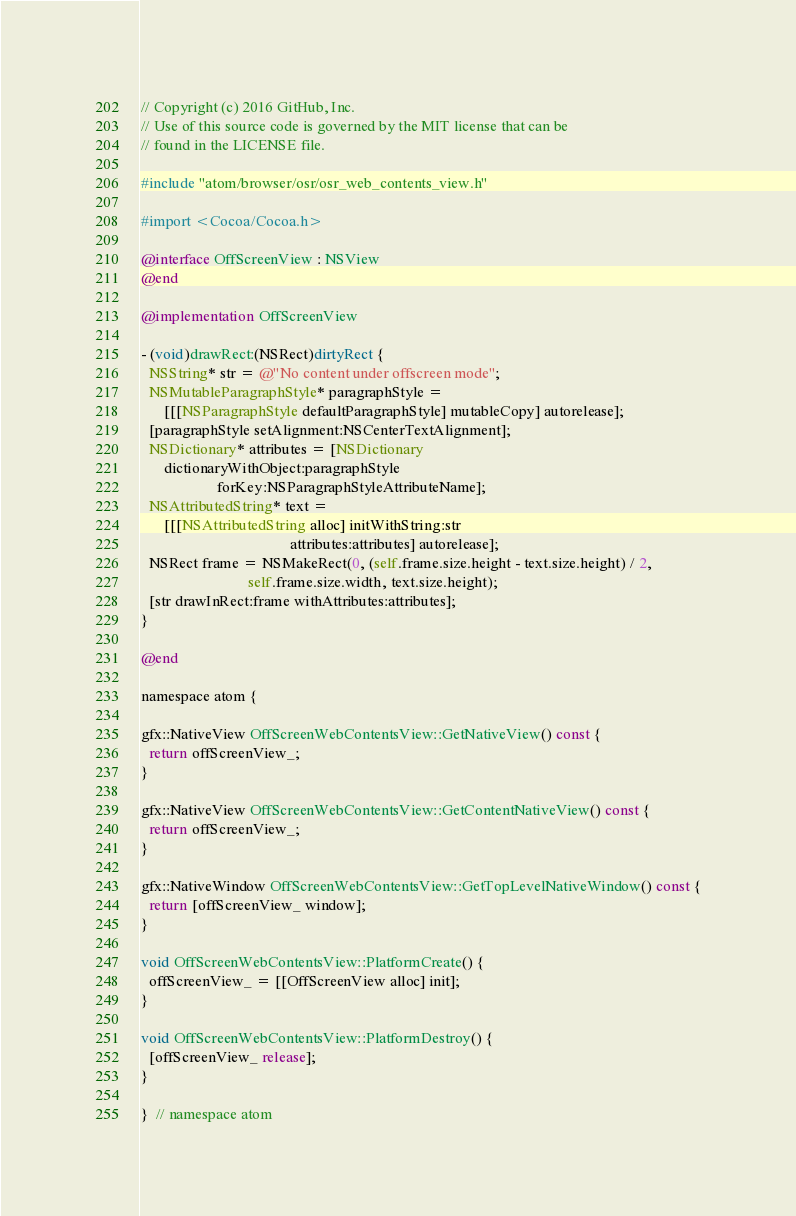<code> <loc_0><loc_0><loc_500><loc_500><_ObjectiveC_>// Copyright (c) 2016 GitHub, Inc.
// Use of this source code is governed by the MIT license that can be
// found in the LICENSE file.

#include "atom/browser/osr/osr_web_contents_view.h"

#import <Cocoa/Cocoa.h>

@interface OffScreenView : NSView
@end

@implementation OffScreenView

- (void)drawRect:(NSRect)dirtyRect {
  NSString* str = @"No content under offscreen mode";
  NSMutableParagraphStyle* paragraphStyle =
      [[[NSParagraphStyle defaultParagraphStyle] mutableCopy] autorelease];
  [paragraphStyle setAlignment:NSCenterTextAlignment];
  NSDictionary* attributes = [NSDictionary
      dictionaryWithObject:paragraphStyle
                    forKey:NSParagraphStyleAttributeName];
  NSAttributedString* text =
      [[[NSAttributedString alloc] initWithString:str
                                       attributes:attributes] autorelease];
  NSRect frame = NSMakeRect(0, (self.frame.size.height - text.size.height) / 2,
                            self.frame.size.width, text.size.height);
  [str drawInRect:frame withAttributes:attributes];
}

@end

namespace atom {

gfx::NativeView OffScreenWebContentsView::GetNativeView() const {
  return offScreenView_;
}

gfx::NativeView OffScreenWebContentsView::GetContentNativeView() const {
  return offScreenView_;
}

gfx::NativeWindow OffScreenWebContentsView::GetTopLevelNativeWindow() const {
  return [offScreenView_ window];
}

void OffScreenWebContentsView::PlatformCreate() {
  offScreenView_ = [[OffScreenView alloc] init];
}

void OffScreenWebContentsView::PlatformDestroy() {
  [offScreenView_ release];
}

}  // namespace atom
</code> 